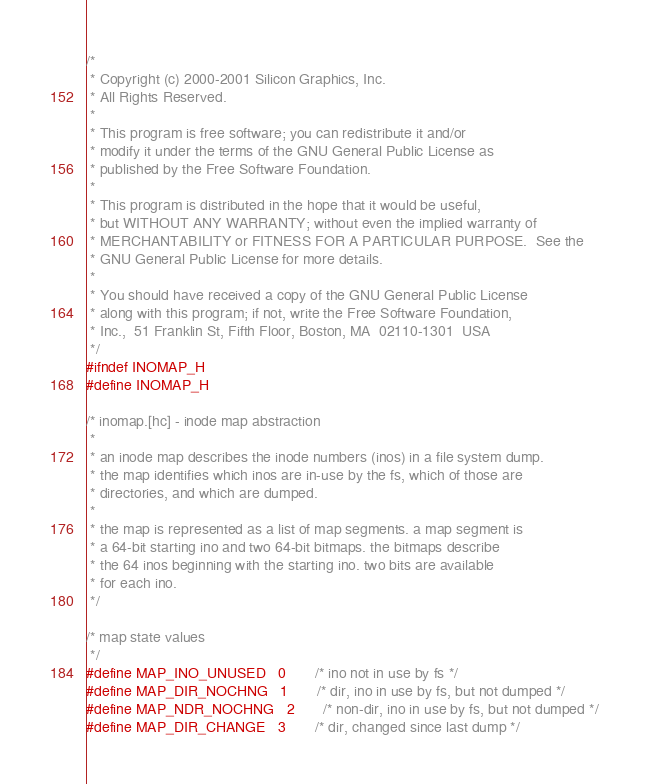Convert code to text. <code><loc_0><loc_0><loc_500><loc_500><_C_>/*
 * Copyright (c) 2000-2001 Silicon Graphics, Inc.
 * All Rights Reserved.
 *
 * This program is free software; you can redistribute it and/or
 * modify it under the terms of the GNU General Public License as
 * published by the Free Software Foundation.
 *
 * This program is distributed in the hope that it would be useful,
 * but WITHOUT ANY WARRANTY; without even the implied warranty of
 * MERCHANTABILITY or FITNESS FOR A PARTICULAR PURPOSE.  See the
 * GNU General Public License for more details.
 *
 * You should have received a copy of the GNU General Public License
 * along with this program; if not, write the Free Software Foundation,
 * Inc.,  51 Franklin St, Fifth Floor, Boston, MA  02110-1301  USA
 */
#ifndef INOMAP_H
#define INOMAP_H

/* inomap.[hc] - inode map abstraction
 *
 * an inode map describes the inode numbers (inos) in a file system dump.
 * the map identifies which inos are in-use by the fs, which of those are
 * directories, and which are dumped.
 *
 * the map is represented as a list of map segments. a map segment is
 * a 64-bit starting ino and two 64-bit bitmaps. the bitmaps describe
 * the 64 inos beginning with the starting ino. two bits are available
 * for each ino.
 */

/* map state values
 */
#define MAP_INO_UNUSED	0       /* ino not in use by fs */
#define MAP_DIR_NOCHNG	1       /* dir, ino in use by fs, but not dumped */
#define MAP_NDR_NOCHNG	2       /* non-dir, ino in use by fs, but not dumped */
#define MAP_DIR_CHANGE	3       /* dir, changed since last dump */</code> 